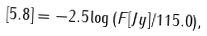Convert formula to latex. <formula><loc_0><loc_0><loc_500><loc_500>[ 5 . 8 ] = - 2 . 5 \log \, ( F [ J y ] / 1 1 5 . 0 ) ,</formula> 